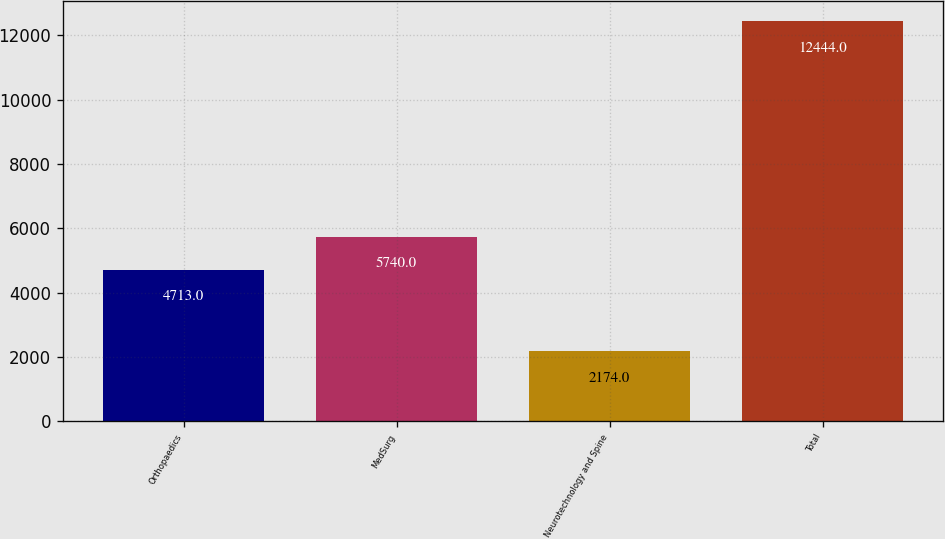Convert chart. <chart><loc_0><loc_0><loc_500><loc_500><bar_chart><fcel>Orthopaedics<fcel>MedSurg<fcel>Neurotechnology and Spine<fcel>Total<nl><fcel>4713<fcel>5740<fcel>2174<fcel>12444<nl></chart> 